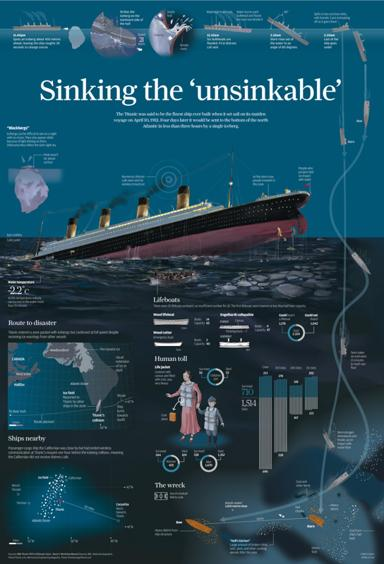Can you explain the 'Ice Conditions' part of the infographic? The 'Ice Conditions' section of the infographic shows the ice warnings received by the Titanic, including paths and locations of icebergs in the North Atlantic on the day of its sinking. It outlines how these warnings were handled and the subsequent route adjustments made by the ship's crew. 